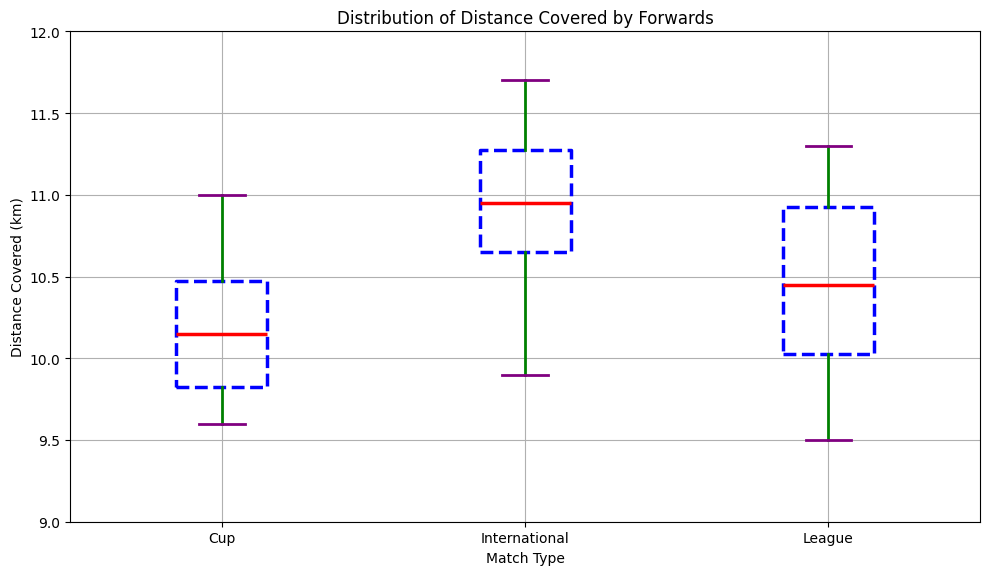Which match type shows the highest median distance covered? The median distance is marked by the red line within each box plot. The red line for "International" matches is higher than those for "League" and "Cup" matches.
Answer: International Which match type has the lowest interquartile range (IQR) for distance covered? The IQR is represented by the height of each box. The "Cup" match type box is the shortest, indicating a smaller IQR.
Answer: Cup Between League and International matches, which match type has a greater variability in distance covered? Variability is indicated by the length of the whiskers and the spread of data points. The "International" matches have longer whiskers, suggesting greater variability.
Answer: International What is the approximate median distance covered during League matches? The median is marked by the red line in the "League" box. It is positioned around 10.3 km.
Answer: 10.3 km Are there any outliers in the International matches' distance covered? Outliers are marked by orange circles outside the whiskers in the box plot. There are no orange circles in the "International" matches.
Answer: No Which match type exhibits the widest range of distances covered from the minimum to the maximum? The range is the difference between the top and bottom whiskers. The whiskers of the "International" matches span a wider distance compared to "League" and "Cup" matches.
Answer: International Compare the median distances covered in Cup and International matches. Which is greater and by how much? The red lines in the "Cup" and "International" boxes represent the median. The median for "International" is around 11.0 km, while for "Cup" it is around 10.2 km. The difference is 11.0 - 10.2 = 0.8 km.
Answer: International by 0.8 km Which match type has the most compact box (smallest IQR) and why might this be significant? The "Cup" match type has the most compact box indicating the smallest IQR. This suggests more consistent performance in terms of distance covered during Cup matches.
Answer: Cup Does any match type show a median distance below 10 km? The medians are all marked by red lines within the boxes. None of the median values is below 10 km for any match type.
Answer: No What is the approximate distance range (from minimum to maximum) for League matches? The bottom and top whiskers of the "League" box plot show the minimum and maximum distances. The range is from around 9.5 km to 11.3 km.
Answer: 9.5 km to 11.3 km 